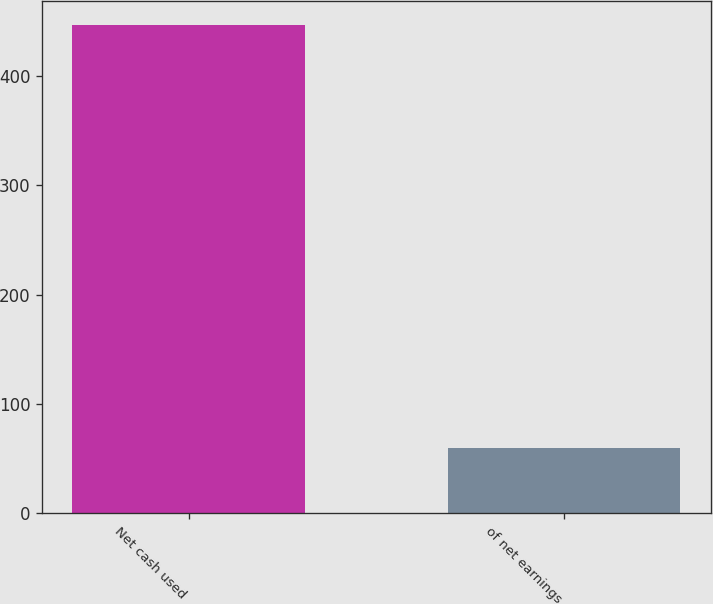Convert chart to OTSL. <chart><loc_0><loc_0><loc_500><loc_500><bar_chart><fcel>Net cash used<fcel>of net earnings<nl><fcel>446.5<fcel>59.4<nl></chart> 